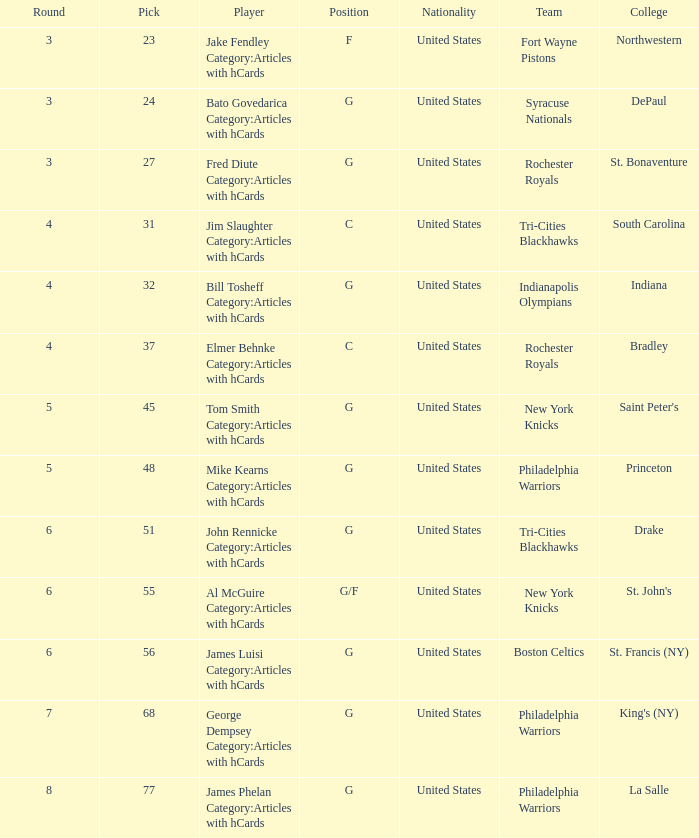What is the aggregate amount of choices for drake participants from the tri-cities blackhawks? 51.0. 